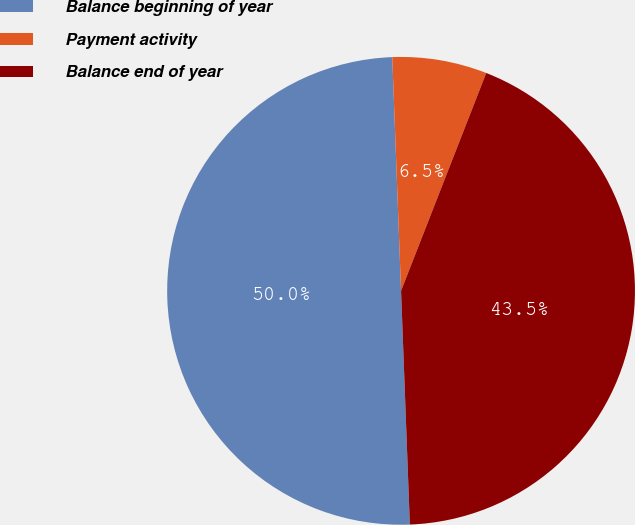Convert chart. <chart><loc_0><loc_0><loc_500><loc_500><pie_chart><fcel>Balance beginning of year<fcel>Payment activity<fcel>Balance end of year<nl><fcel>50.0%<fcel>6.53%<fcel>43.47%<nl></chart> 